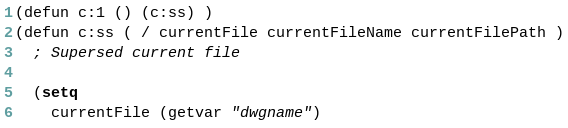<code> <loc_0><loc_0><loc_500><loc_500><_Lisp_>(defun c:1 () (c:ss) )
(defun c:ss ( / currentFile currentFileName currentFilePath )
  ; Supersed current file

  (setq
    currentFile (getvar "dwgname")</code> 